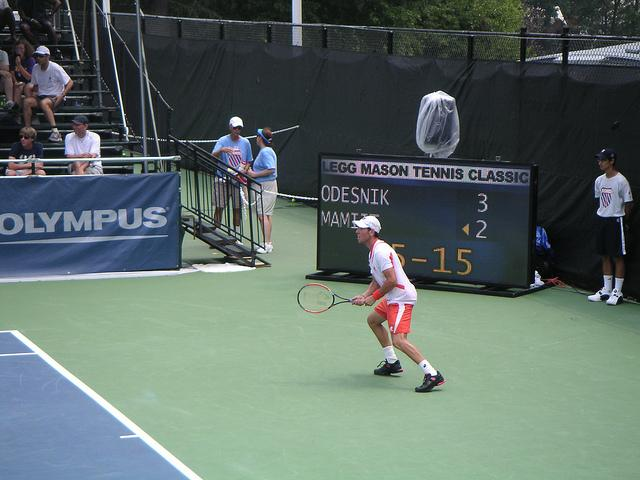What type of tennis game is being played here?

Choices:
A) doubles
B) singles
C) handball
D) mixed doubles singles 